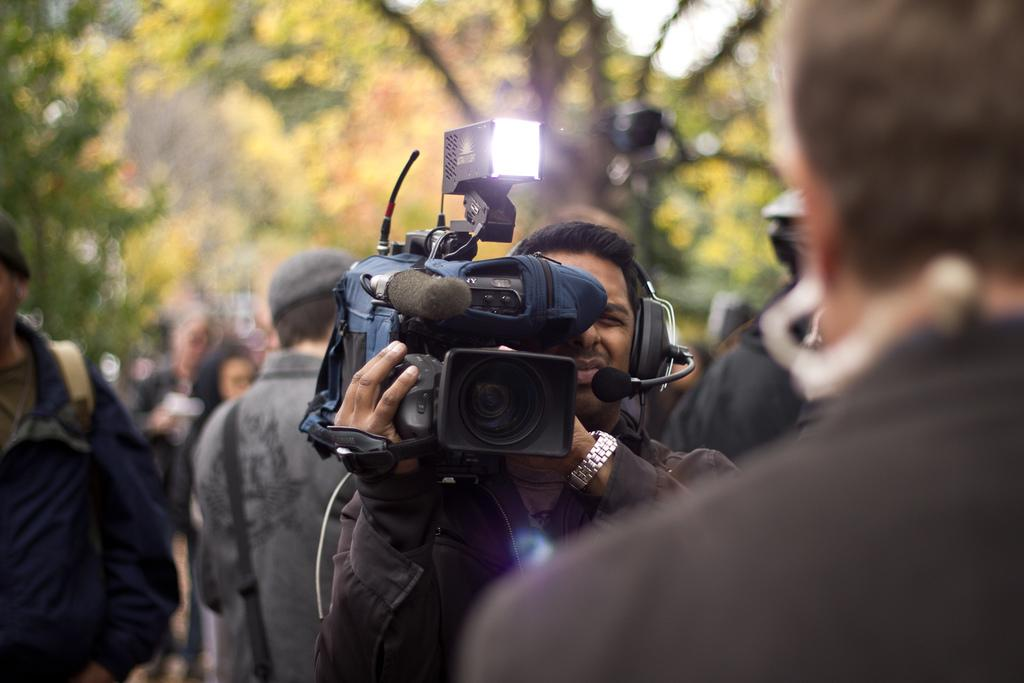What is the man in the image doing? The man is recording a video. How many people are visible around the man? There are many people around the man. What can be seen in the background of the image? There are trees in the background of the image. What type of blood is visible on the man's shirt in the image? There is no blood visible on the man's shirt in the image. In which direction is the man facing in the image? The provided facts do not specify the direction the man is facing in the image. 